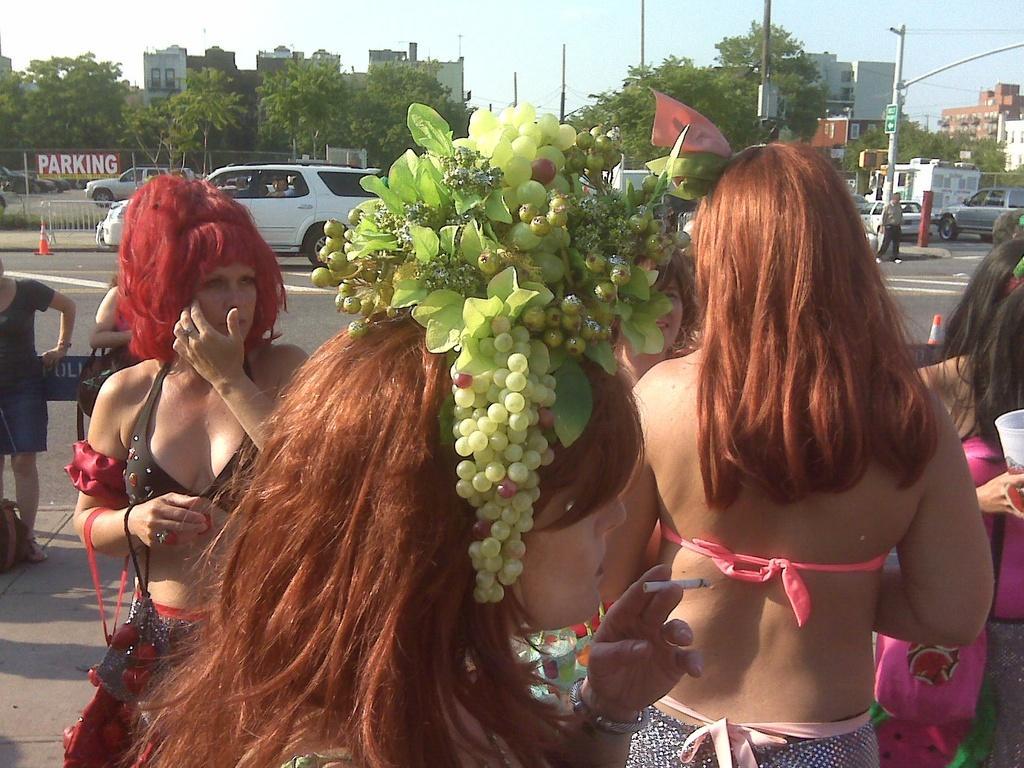Can you describe this image briefly? This picture is taken outside the city. Here, we see many women standing on road. We see grapes on head of the woman who is wearing green dress and behind them, we see vehicles moving on the road and beside that, we see a board on which "Parking" is written and behind that, we see many buildings and trees. 